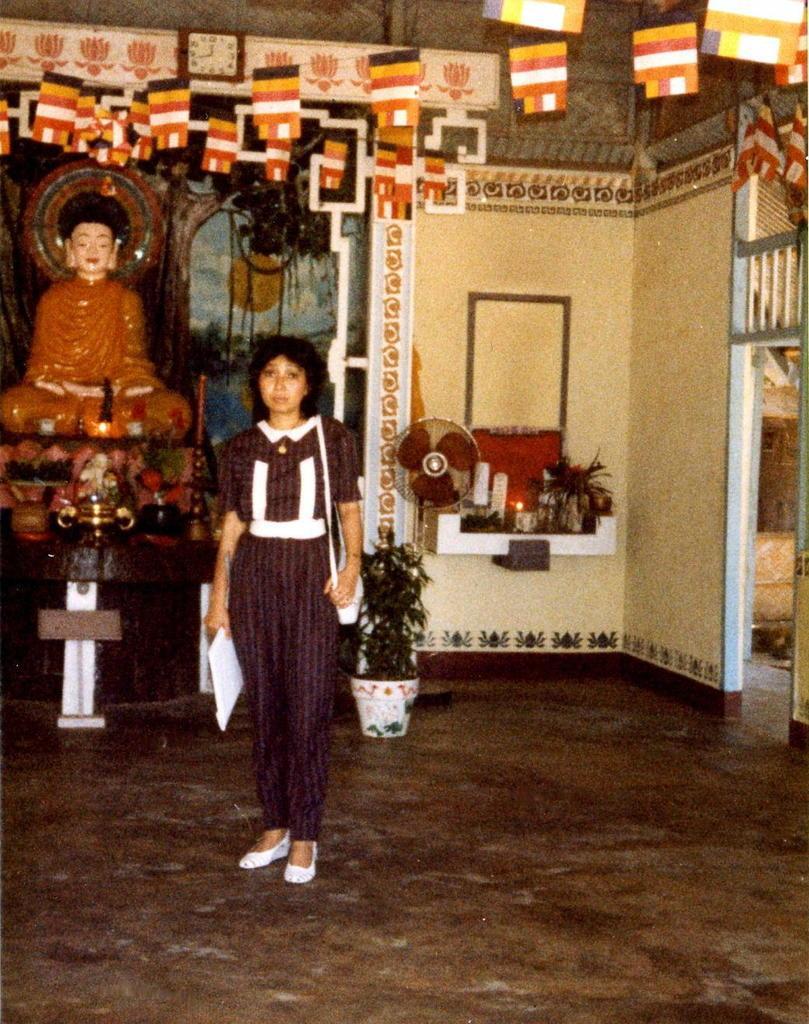Could you give a brief overview of what you see in this image? In this picture I can see a woman standing in front and I see that she is holding a thing and carrying a bag. In the background I can see a fan, a statue, few plants, decoration and I can see the wall. 